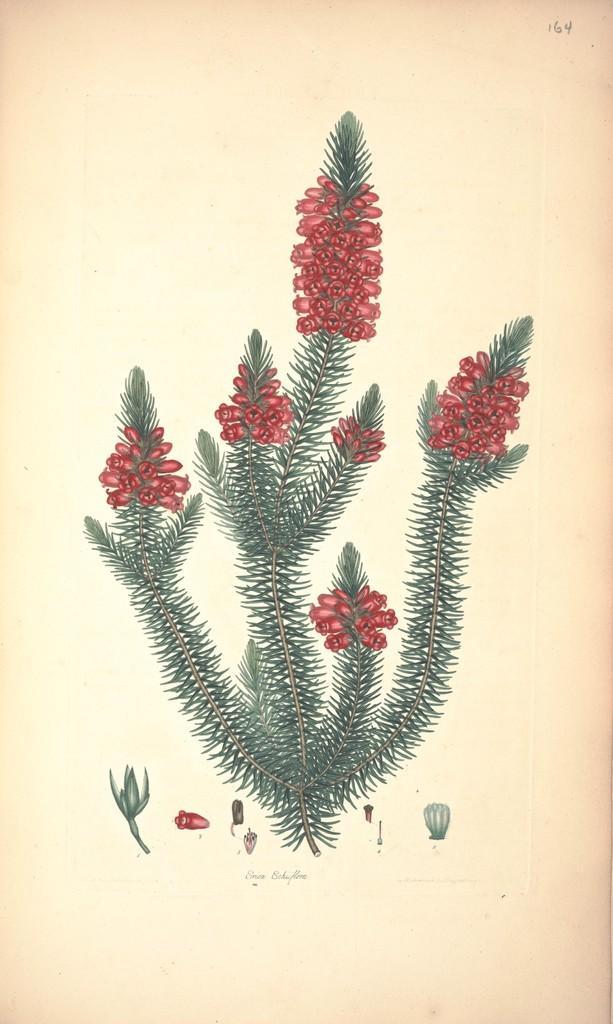Please provide a concise description of this image. This image consists of a poster on which there is an art of a plant with red flowers. 